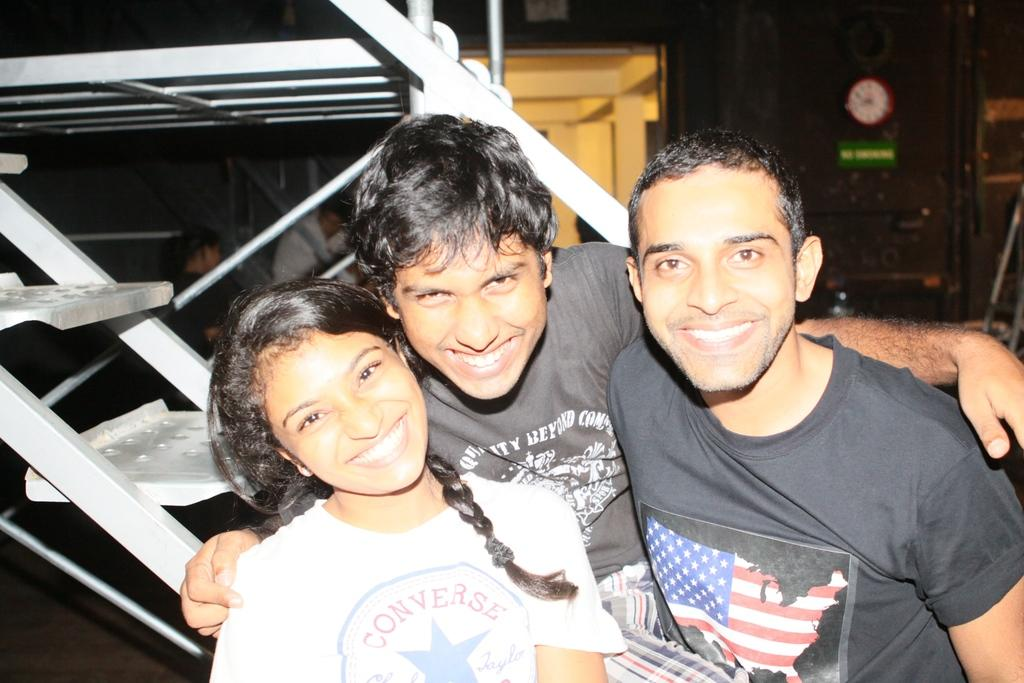How many people are in the image? There are five people in the image. What are the people in the image doing? Three persons are smiling and posing, while the other two are also present in the image. What object can be seen in the image that displays time? There is a clock in the image. What object in the image might indicate a specific location or name? There is a name board in the image. What can be seen in the background of the image? There are some objects in the background of the image. What type of doctor is present in the image? There is no doctor present in the image. How many chairs can be seen in the image? The provided facts do not mention chairs, so it is impossible to determine their number from the image. 